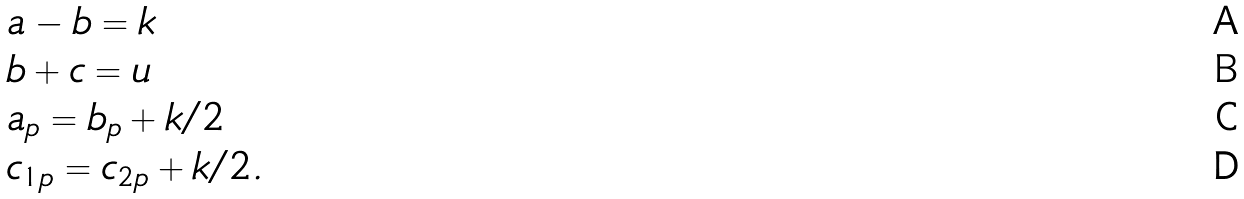<formula> <loc_0><loc_0><loc_500><loc_500>& a - b = k \\ & b + c = u \\ & a _ { p } = b _ { p } + k / 2 \\ & c _ { 1 p } = c _ { 2 p } + k / 2 .</formula> 